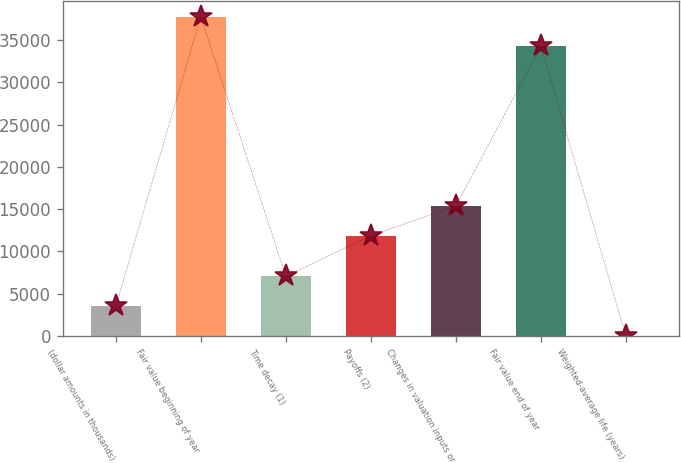<chart> <loc_0><loc_0><loc_500><loc_500><bar_chart><fcel>(dollar amounts in thousands)<fcel>Fair value beginning of year<fcel>Time decay (1)<fcel>Payoffs (2)<fcel>Changes in valuation inputs or<fcel>Fair value end of year<fcel>Weighted-average life (years)<nl><fcel>3523.98<fcel>37755.8<fcel>7043.76<fcel>11851<fcel>15370.8<fcel>34236<fcel>4.2<nl></chart> 